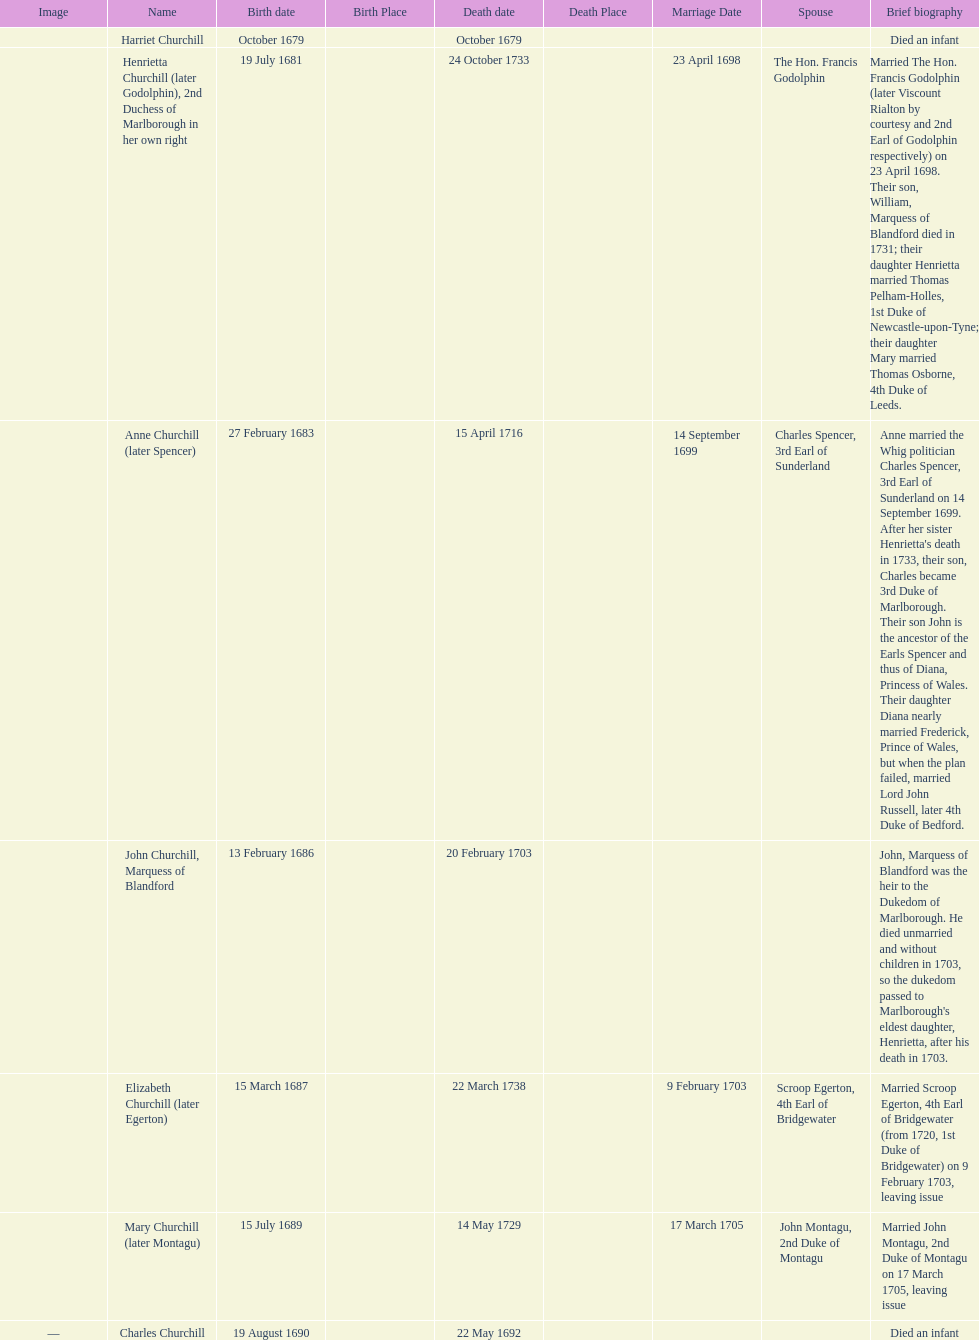Who was born before henrietta churchhill? Harriet Churchill. 